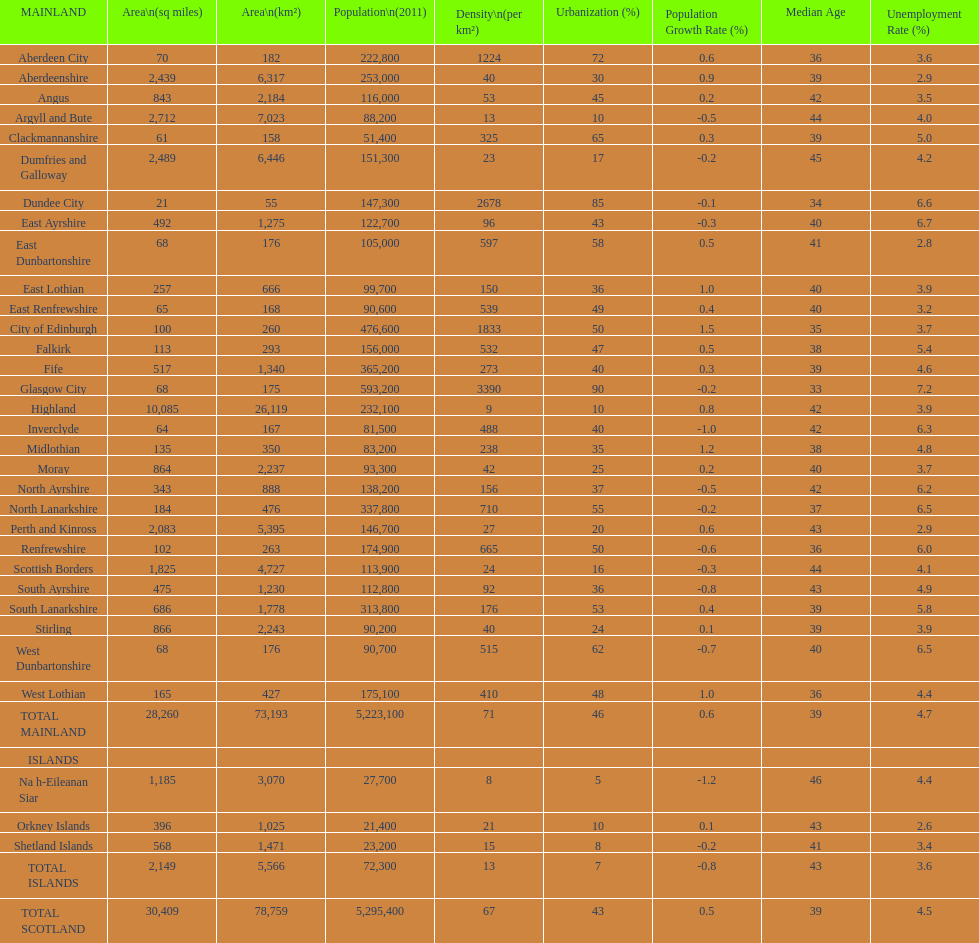Which mainland has the least population? Clackmannanshire. 